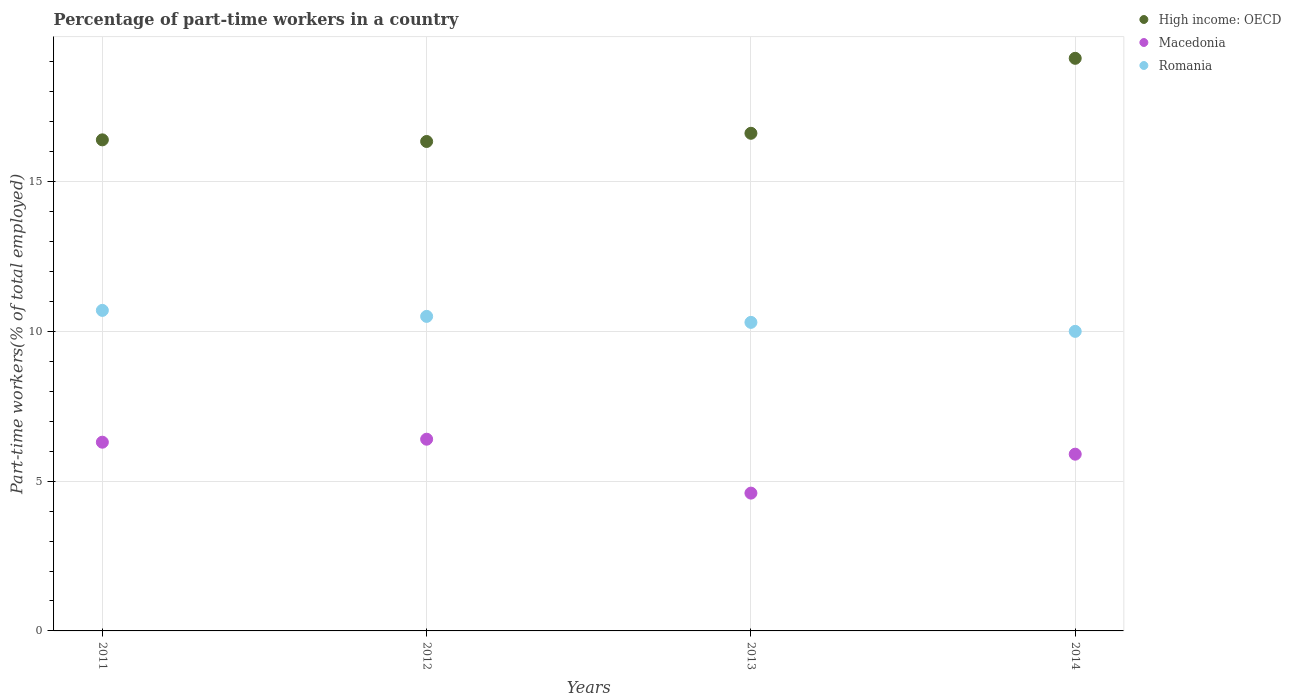What is the percentage of part-time workers in High income: OECD in 2014?
Your answer should be very brief. 19.12. Across all years, what is the maximum percentage of part-time workers in Macedonia?
Keep it short and to the point. 6.4. Across all years, what is the minimum percentage of part-time workers in Macedonia?
Provide a short and direct response. 4.6. What is the total percentage of part-time workers in Romania in the graph?
Ensure brevity in your answer.  41.5. What is the difference between the percentage of part-time workers in Romania in 2012 and that in 2013?
Offer a terse response. 0.2. What is the difference between the percentage of part-time workers in High income: OECD in 2014 and the percentage of part-time workers in Romania in 2012?
Your response must be concise. 8.62. What is the average percentage of part-time workers in Macedonia per year?
Provide a succinct answer. 5.8. In the year 2013, what is the difference between the percentage of part-time workers in High income: OECD and percentage of part-time workers in Macedonia?
Give a very brief answer. 12.01. What is the ratio of the percentage of part-time workers in Macedonia in 2012 to that in 2014?
Give a very brief answer. 1.08. Is the difference between the percentage of part-time workers in High income: OECD in 2011 and 2012 greater than the difference between the percentage of part-time workers in Macedonia in 2011 and 2012?
Your answer should be very brief. Yes. What is the difference between the highest and the second highest percentage of part-time workers in Macedonia?
Your response must be concise. 0.1. What is the difference between the highest and the lowest percentage of part-time workers in Macedonia?
Keep it short and to the point. 1.8. In how many years, is the percentage of part-time workers in Romania greater than the average percentage of part-time workers in Romania taken over all years?
Give a very brief answer. 2. Is the sum of the percentage of part-time workers in High income: OECD in 2012 and 2014 greater than the maximum percentage of part-time workers in Romania across all years?
Keep it short and to the point. Yes. Is it the case that in every year, the sum of the percentage of part-time workers in High income: OECD and percentage of part-time workers in Macedonia  is greater than the percentage of part-time workers in Romania?
Ensure brevity in your answer.  Yes. Does the percentage of part-time workers in Romania monotonically increase over the years?
Provide a short and direct response. No. Is the percentage of part-time workers in Romania strictly less than the percentage of part-time workers in High income: OECD over the years?
Provide a short and direct response. Yes. What is the difference between two consecutive major ticks on the Y-axis?
Provide a short and direct response. 5. Where does the legend appear in the graph?
Keep it short and to the point. Top right. How are the legend labels stacked?
Provide a succinct answer. Vertical. What is the title of the graph?
Offer a very short reply. Percentage of part-time workers in a country. What is the label or title of the X-axis?
Provide a succinct answer. Years. What is the label or title of the Y-axis?
Provide a succinct answer. Part-time workers(% of total employed). What is the Part-time workers(% of total employed) of High income: OECD in 2011?
Offer a very short reply. 16.39. What is the Part-time workers(% of total employed) of Macedonia in 2011?
Provide a succinct answer. 6.3. What is the Part-time workers(% of total employed) in Romania in 2011?
Provide a short and direct response. 10.7. What is the Part-time workers(% of total employed) in High income: OECD in 2012?
Offer a terse response. 16.34. What is the Part-time workers(% of total employed) in Macedonia in 2012?
Offer a very short reply. 6.4. What is the Part-time workers(% of total employed) in High income: OECD in 2013?
Make the answer very short. 16.61. What is the Part-time workers(% of total employed) in Macedonia in 2013?
Your response must be concise. 4.6. What is the Part-time workers(% of total employed) in Romania in 2013?
Your response must be concise. 10.3. What is the Part-time workers(% of total employed) in High income: OECD in 2014?
Make the answer very short. 19.12. What is the Part-time workers(% of total employed) of Macedonia in 2014?
Provide a short and direct response. 5.9. What is the Part-time workers(% of total employed) of Romania in 2014?
Offer a very short reply. 10. Across all years, what is the maximum Part-time workers(% of total employed) of High income: OECD?
Your answer should be very brief. 19.12. Across all years, what is the maximum Part-time workers(% of total employed) of Macedonia?
Your answer should be very brief. 6.4. Across all years, what is the maximum Part-time workers(% of total employed) of Romania?
Make the answer very short. 10.7. Across all years, what is the minimum Part-time workers(% of total employed) in High income: OECD?
Offer a very short reply. 16.34. Across all years, what is the minimum Part-time workers(% of total employed) of Macedonia?
Make the answer very short. 4.6. Across all years, what is the minimum Part-time workers(% of total employed) in Romania?
Offer a very short reply. 10. What is the total Part-time workers(% of total employed) of High income: OECD in the graph?
Your response must be concise. 68.46. What is the total Part-time workers(% of total employed) in Macedonia in the graph?
Your response must be concise. 23.2. What is the total Part-time workers(% of total employed) in Romania in the graph?
Ensure brevity in your answer.  41.5. What is the difference between the Part-time workers(% of total employed) in High income: OECD in 2011 and that in 2012?
Give a very brief answer. 0.05. What is the difference between the Part-time workers(% of total employed) of High income: OECD in 2011 and that in 2013?
Give a very brief answer. -0.22. What is the difference between the Part-time workers(% of total employed) of High income: OECD in 2011 and that in 2014?
Make the answer very short. -2.72. What is the difference between the Part-time workers(% of total employed) in High income: OECD in 2012 and that in 2013?
Ensure brevity in your answer.  -0.27. What is the difference between the Part-time workers(% of total employed) in Romania in 2012 and that in 2013?
Offer a very short reply. 0.2. What is the difference between the Part-time workers(% of total employed) in High income: OECD in 2012 and that in 2014?
Ensure brevity in your answer.  -2.78. What is the difference between the Part-time workers(% of total employed) in Macedonia in 2012 and that in 2014?
Your answer should be compact. 0.5. What is the difference between the Part-time workers(% of total employed) of High income: OECD in 2013 and that in 2014?
Your answer should be compact. -2.5. What is the difference between the Part-time workers(% of total employed) of Macedonia in 2013 and that in 2014?
Offer a very short reply. -1.3. What is the difference between the Part-time workers(% of total employed) of High income: OECD in 2011 and the Part-time workers(% of total employed) of Macedonia in 2012?
Offer a very short reply. 9.99. What is the difference between the Part-time workers(% of total employed) of High income: OECD in 2011 and the Part-time workers(% of total employed) of Romania in 2012?
Your response must be concise. 5.89. What is the difference between the Part-time workers(% of total employed) in High income: OECD in 2011 and the Part-time workers(% of total employed) in Macedonia in 2013?
Your response must be concise. 11.79. What is the difference between the Part-time workers(% of total employed) of High income: OECD in 2011 and the Part-time workers(% of total employed) of Romania in 2013?
Your response must be concise. 6.09. What is the difference between the Part-time workers(% of total employed) in Macedonia in 2011 and the Part-time workers(% of total employed) in Romania in 2013?
Keep it short and to the point. -4. What is the difference between the Part-time workers(% of total employed) of High income: OECD in 2011 and the Part-time workers(% of total employed) of Macedonia in 2014?
Offer a very short reply. 10.49. What is the difference between the Part-time workers(% of total employed) in High income: OECD in 2011 and the Part-time workers(% of total employed) in Romania in 2014?
Offer a very short reply. 6.39. What is the difference between the Part-time workers(% of total employed) in High income: OECD in 2012 and the Part-time workers(% of total employed) in Macedonia in 2013?
Make the answer very short. 11.74. What is the difference between the Part-time workers(% of total employed) in High income: OECD in 2012 and the Part-time workers(% of total employed) in Romania in 2013?
Offer a terse response. 6.04. What is the difference between the Part-time workers(% of total employed) in Macedonia in 2012 and the Part-time workers(% of total employed) in Romania in 2013?
Offer a very short reply. -3.9. What is the difference between the Part-time workers(% of total employed) of High income: OECD in 2012 and the Part-time workers(% of total employed) of Macedonia in 2014?
Provide a succinct answer. 10.44. What is the difference between the Part-time workers(% of total employed) of High income: OECD in 2012 and the Part-time workers(% of total employed) of Romania in 2014?
Offer a very short reply. 6.34. What is the difference between the Part-time workers(% of total employed) in Macedonia in 2012 and the Part-time workers(% of total employed) in Romania in 2014?
Your answer should be very brief. -3.6. What is the difference between the Part-time workers(% of total employed) in High income: OECD in 2013 and the Part-time workers(% of total employed) in Macedonia in 2014?
Give a very brief answer. 10.71. What is the difference between the Part-time workers(% of total employed) in High income: OECD in 2013 and the Part-time workers(% of total employed) in Romania in 2014?
Keep it short and to the point. 6.61. What is the average Part-time workers(% of total employed) of High income: OECD per year?
Keep it short and to the point. 17.11. What is the average Part-time workers(% of total employed) in Macedonia per year?
Ensure brevity in your answer.  5.8. What is the average Part-time workers(% of total employed) in Romania per year?
Provide a short and direct response. 10.38. In the year 2011, what is the difference between the Part-time workers(% of total employed) of High income: OECD and Part-time workers(% of total employed) of Macedonia?
Make the answer very short. 10.09. In the year 2011, what is the difference between the Part-time workers(% of total employed) of High income: OECD and Part-time workers(% of total employed) of Romania?
Your answer should be compact. 5.69. In the year 2011, what is the difference between the Part-time workers(% of total employed) of Macedonia and Part-time workers(% of total employed) of Romania?
Your answer should be compact. -4.4. In the year 2012, what is the difference between the Part-time workers(% of total employed) in High income: OECD and Part-time workers(% of total employed) in Macedonia?
Your answer should be very brief. 9.94. In the year 2012, what is the difference between the Part-time workers(% of total employed) in High income: OECD and Part-time workers(% of total employed) in Romania?
Offer a very short reply. 5.84. In the year 2012, what is the difference between the Part-time workers(% of total employed) in Macedonia and Part-time workers(% of total employed) in Romania?
Provide a short and direct response. -4.1. In the year 2013, what is the difference between the Part-time workers(% of total employed) of High income: OECD and Part-time workers(% of total employed) of Macedonia?
Offer a terse response. 12.01. In the year 2013, what is the difference between the Part-time workers(% of total employed) in High income: OECD and Part-time workers(% of total employed) in Romania?
Offer a very short reply. 6.31. In the year 2013, what is the difference between the Part-time workers(% of total employed) of Macedonia and Part-time workers(% of total employed) of Romania?
Offer a very short reply. -5.7. In the year 2014, what is the difference between the Part-time workers(% of total employed) of High income: OECD and Part-time workers(% of total employed) of Macedonia?
Give a very brief answer. 13.21. In the year 2014, what is the difference between the Part-time workers(% of total employed) of High income: OECD and Part-time workers(% of total employed) of Romania?
Provide a short and direct response. 9.12. What is the ratio of the Part-time workers(% of total employed) in High income: OECD in 2011 to that in 2012?
Make the answer very short. 1. What is the ratio of the Part-time workers(% of total employed) of Macedonia in 2011 to that in 2012?
Your response must be concise. 0.98. What is the ratio of the Part-time workers(% of total employed) in Macedonia in 2011 to that in 2013?
Offer a terse response. 1.37. What is the ratio of the Part-time workers(% of total employed) in Romania in 2011 to that in 2013?
Keep it short and to the point. 1.04. What is the ratio of the Part-time workers(% of total employed) of High income: OECD in 2011 to that in 2014?
Provide a short and direct response. 0.86. What is the ratio of the Part-time workers(% of total employed) in Macedonia in 2011 to that in 2014?
Make the answer very short. 1.07. What is the ratio of the Part-time workers(% of total employed) of Romania in 2011 to that in 2014?
Ensure brevity in your answer.  1.07. What is the ratio of the Part-time workers(% of total employed) of High income: OECD in 2012 to that in 2013?
Offer a very short reply. 0.98. What is the ratio of the Part-time workers(% of total employed) in Macedonia in 2012 to that in 2013?
Your answer should be very brief. 1.39. What is the ratio of the Part-time workers(% of total employed) of Romania in 2012 to that in 2013?
Your response must be concise. 1.02. What is the ratio of the Part-time workers(% of total employed) in High income: OECD in 2012 to that in 2014?
Offer a terse response. 0.85. What is the ratio of the Part-time workers(% of total employed) in Macedonia in 2012 to that in 2014?
Provide a short and direct response. 1.08. What is the ratio of the Part-time workers(% of total employed) of Romania in 2012 to that in 2014?
Provide a succinct answer. 1.05. What is the ratio of the Part-time workers(% of total employed) of High income: OECD in 2013 to that in 2014?
Your response must be concise. 0.87. What is the ratio of the Part-time workers(% of total employed) of Macedonia in 2013 to that in 2014?
Provide a succinct answer. 0.78. What is the difference between the highest and the second highest Part-time workers(% of total employed) of High income: OECD?
Make the answer very short. 2.5. What is the difference between the highest and the second highest Part-time workers(% of total employed) in Romania?
Your answer should be compact. 0.2. What is the difference between the highest and the lowest Part-time workers(% of total employed) in High income: OECD?
Your answer should be compact. 2.78. What is the difference between the highest and the lowest Part-time workers(% of total employed) of Macedonia?
Make the answer very short. 1.8. 